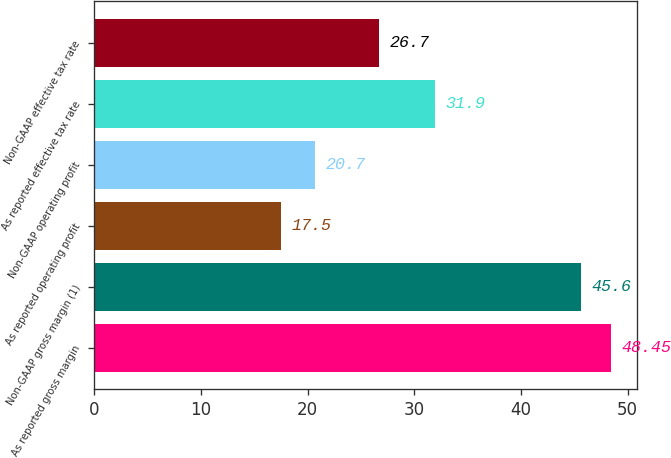<chart> <loc_0><loc_0><loc_500><loc_500><bar_chart><fcel>As reported gross margin<fcel>Non-GAAP gross margin (1)<fcel>As reported operating profit<fcel>Non-GAAP operating profit<fcel>As reported effective tax rate<fcel>Non-GAAP effective tax rate<nl><fcel>48.45<fcel>45.6<fcel>17.5<fcel>20.7<fcel>31.9<fcel>26.7<nl></chart> 